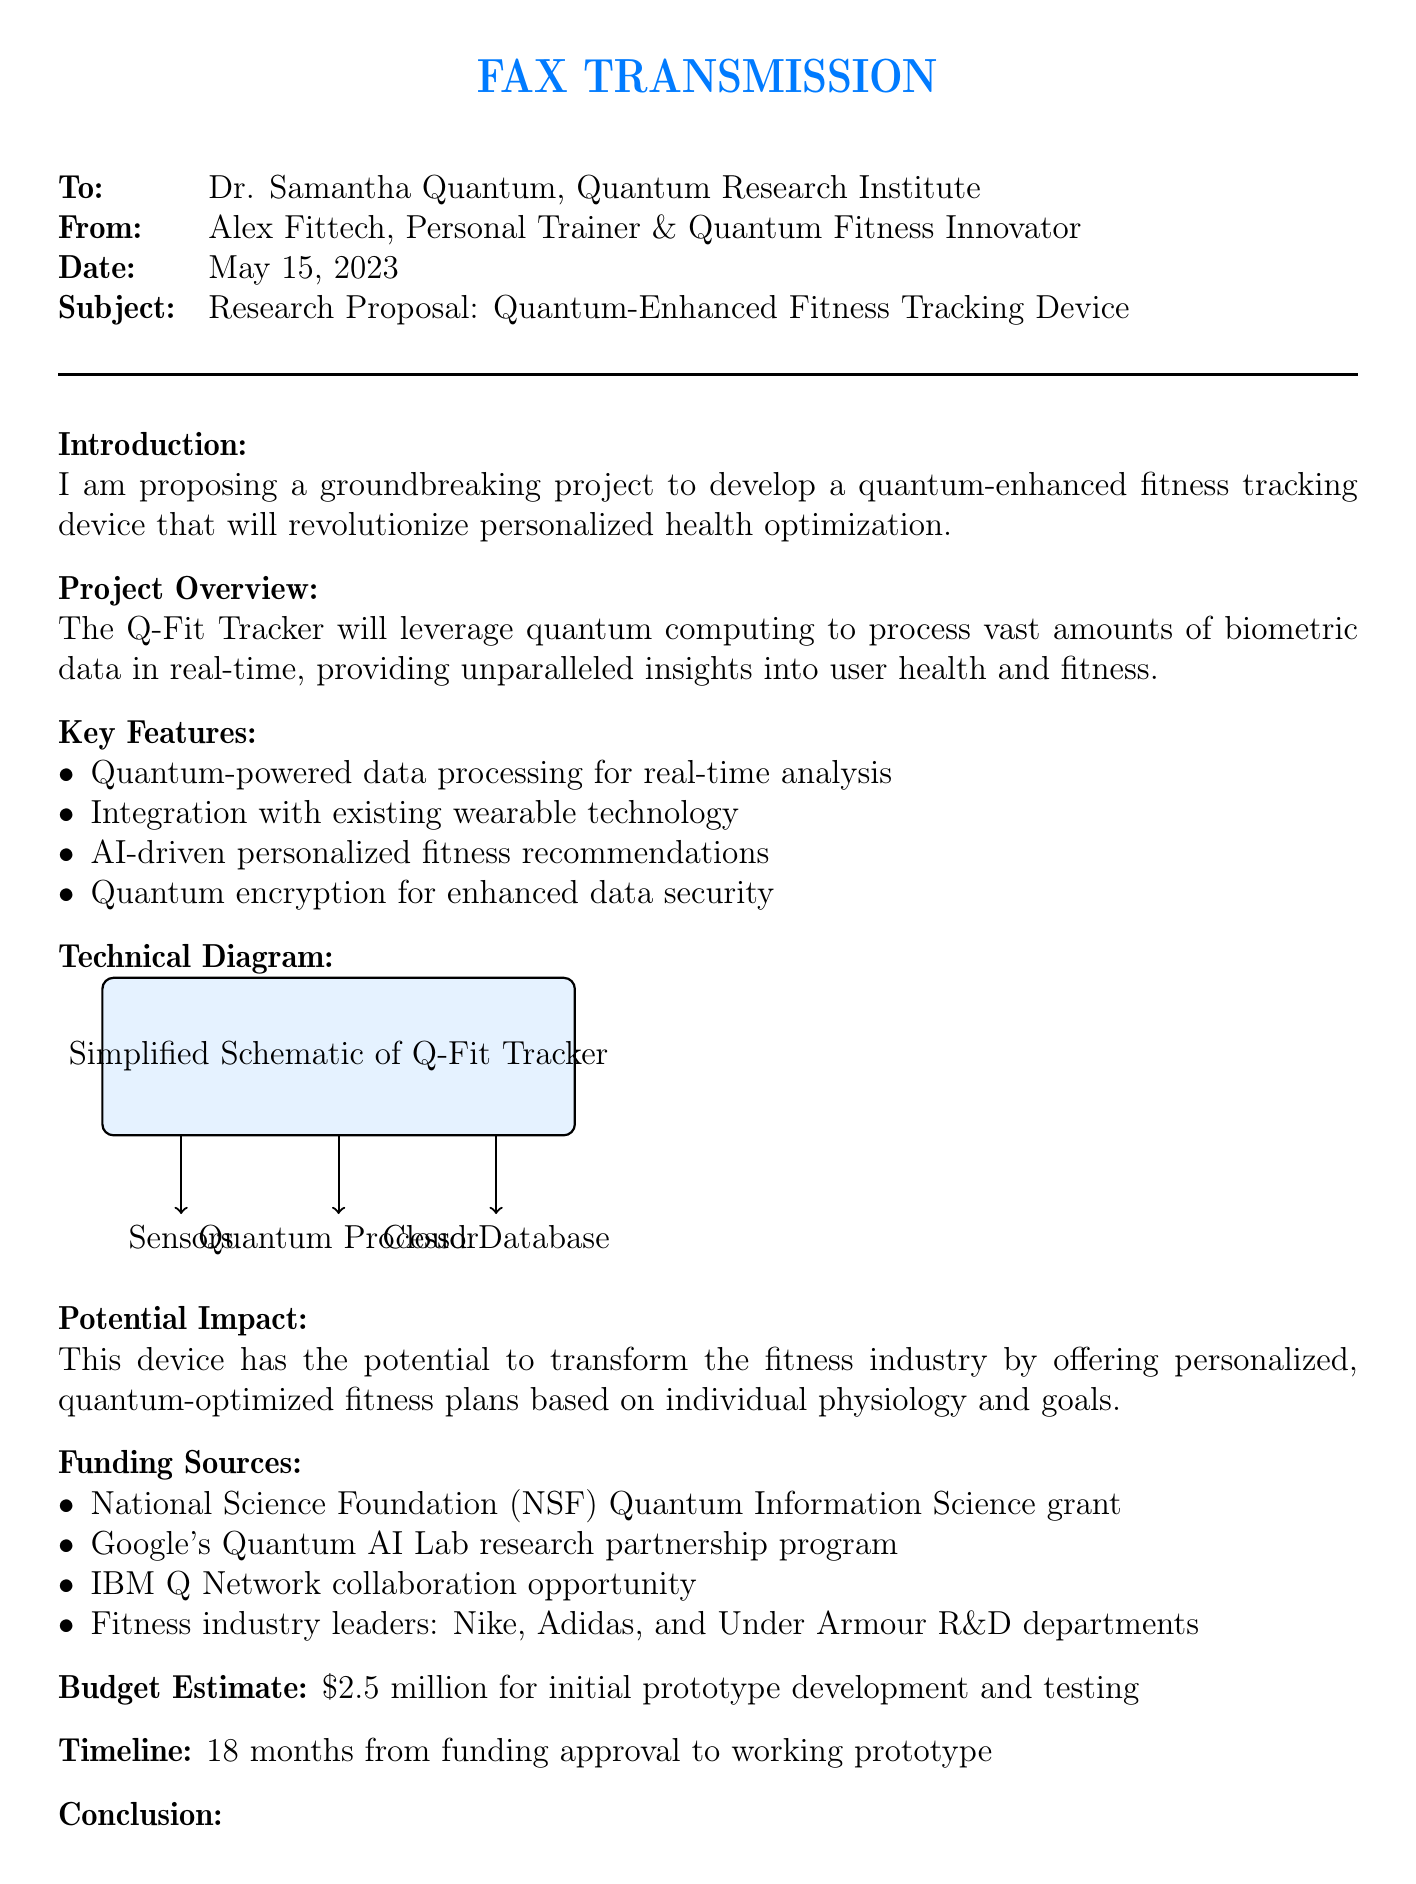What is the name of the proposed device? The name provided in the document for the proposed device is Q-Fit Tracker.
Answer: Q-Fit Tracker Who is the sender of the fax? The sender of the fax is Alex Fittech, who is identified as a Personal Trainer & Quantum Fitness Innovator.
Answer: Alex Fittech What is the date of the fax? The date of the fax is specified as May 15, 2023.
Answer: May 15, 2023 What is the estimated budget for the initial prototype development? The estimated budget mentioned in the document for the initial prototype development is $2.5 million.
Answer: $2.5 million What is the timeline from funding approval to working prototype? The timeline stated in the document is 18 months from funding approval to working prototype.
Answer: 18 months Which funding source is a partnership program from Google? The funding source that is a partnership program from Google is the Google Quantum AI Lab research partnership program.
Answer: Google Quantum AI Lab What feature enhances data security in the proposed device? The feature that enhances data security in the proposed device is quantum encryption.
Answer: Quantum encryption What type of diagram is included in the proposal? The type of diagram included in the proposal is a simplified schematic of the Q-Fit Tracker.
Answer: Simplified Schematic What is the potential impact mentioned in the document? The potential impact mentioned is that the device could transform the fitness industry by offering personalized fitness plans.
Answer: Transform the fitness industry What does the sender seek from Dr. Samantha Quantum? The sender seeks expertise and support to bring the quantum fitness technology to life.
Answer: Expertise and support 